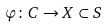Convert formula to latex. <formula><loc_0><loc_0><loc_500><loc_500>\varphi \colon C \to X \subset S</formula> 